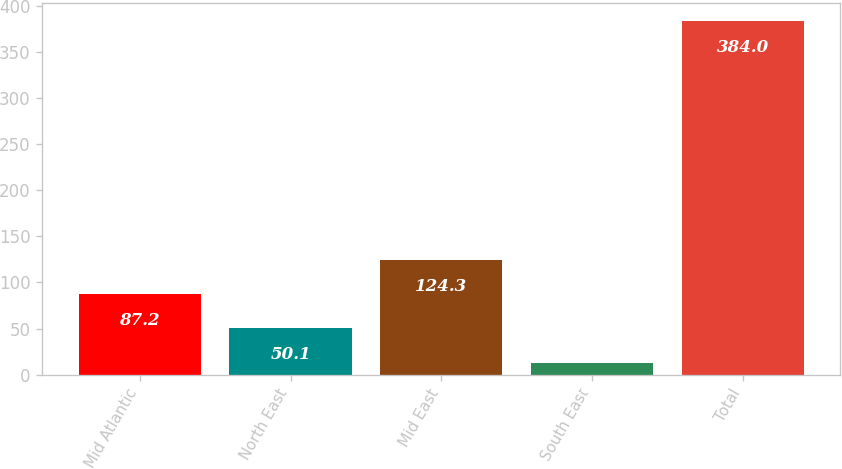Convert chart. <chart><loc_0><loc_0><loc_500><loc_500><bar_chart><fcel>Mid Atlantic<fcel>North East<fcel>Mid East<fcel>South East<fcel>Total<nl><fcel>87.2<fcel>50.1<fcel>124.3<fcel>13<fcel>384<nl></chart> 